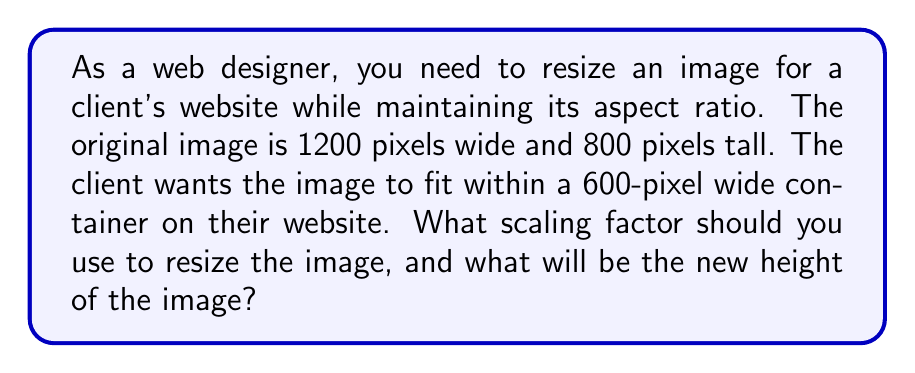Can you answer this question? To solve this problem, we need to use the concept of linear scaling and aspect ratio preservation. Let's approach this step-by-step:

1. Define the scaling factor:
   Let $s$ be the scaling factor we need to determine.

2. Set up the equation for the new width:
   $$1200s = 600$$

3. Solve for $s$:
   $$s = \frac{600}{1200} = 0.5$$

4. To maintain the aspect ratio, we apply the same scaling factor to both dimensions. So, the new height will be:
   $$\text{New Height} = 800s = 800 \cdot 0.5 = 400\text{ pixels}$$

5. Verify that the aspect ratio is maintained:
   Original aspect ratio: $\frac{1200}{800} = 1.5$
   New aspect ratio: $\frac{600}{400} = 1.5$

The aspect ratio remains the same, confirming that our scaling preserves the image's proportions.
Answer: The scaling factor is $0.5$, and the new height of the image will be $400$ pixels. 